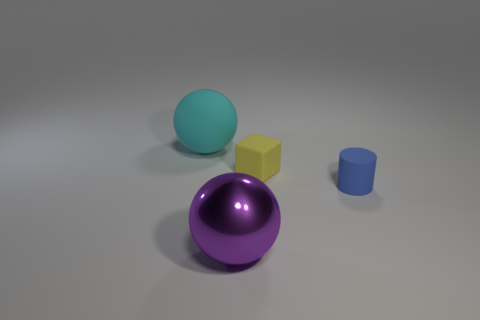Subtract all cylinders. How many objects are left? 3 Add 3 cyan rubber blocks. How many objects exist? 7 Subtract 1 spheres. How many spheres are left? 1 Add 4 tiny matte cubes. How many tiny matte cubes are left? 5 Add 4 big purple metallic objects. How many big purple metallic objects exist? 5 Subtract all cyan spheres. How many spheres are left? 1 Subtract 0 cyan cylinders. How many objects are left? 4 Subtract all red blocks. Subtract all red spheres. How many blocks are left? 1 Subtract all red blocks. How many yellow spheres are left? 0 Subtract all yellow shiny objects. Subtract all rubber balls. How many objects are left? 3 